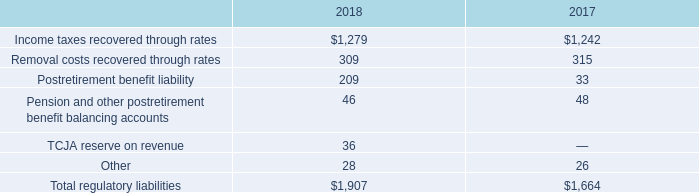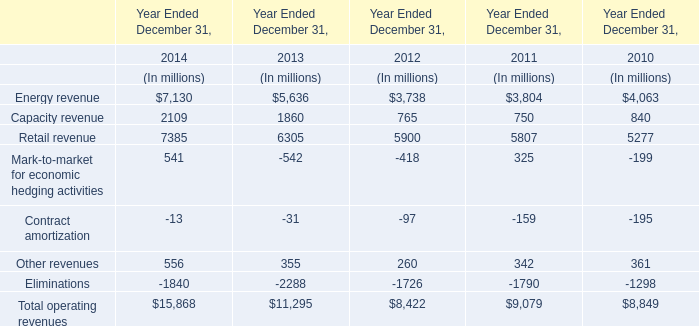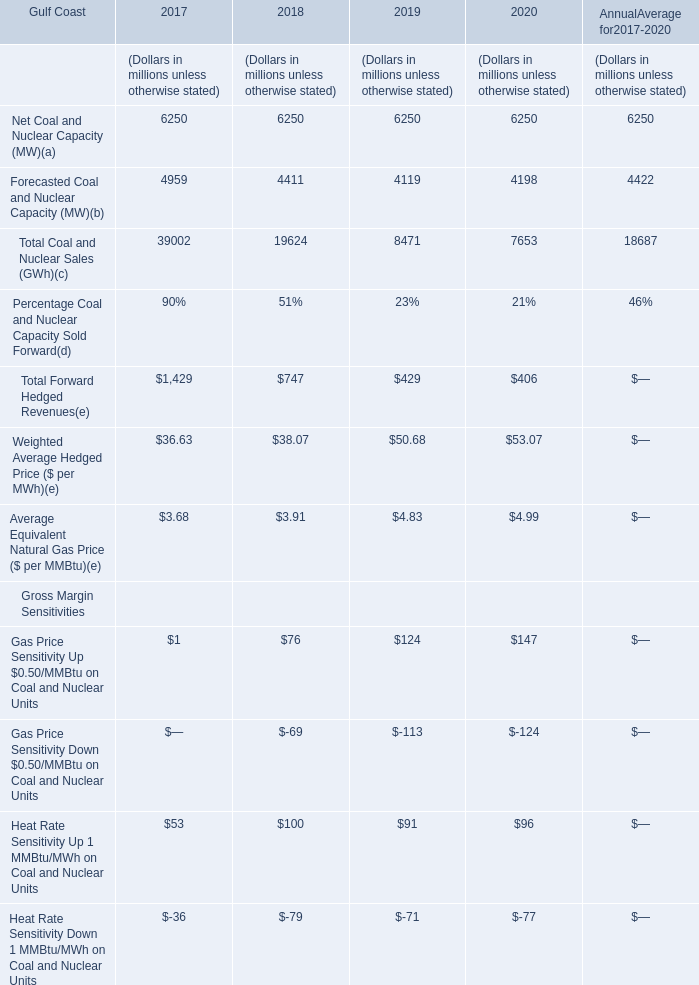In the year with lowest amount of Forecasted Coal and Nuclear Capacity, what's the increasing rate of Total Coal and Nuclear Sales? 
Computations: ((7653 - 8471) / 8471)
Answer: -0.09656. 